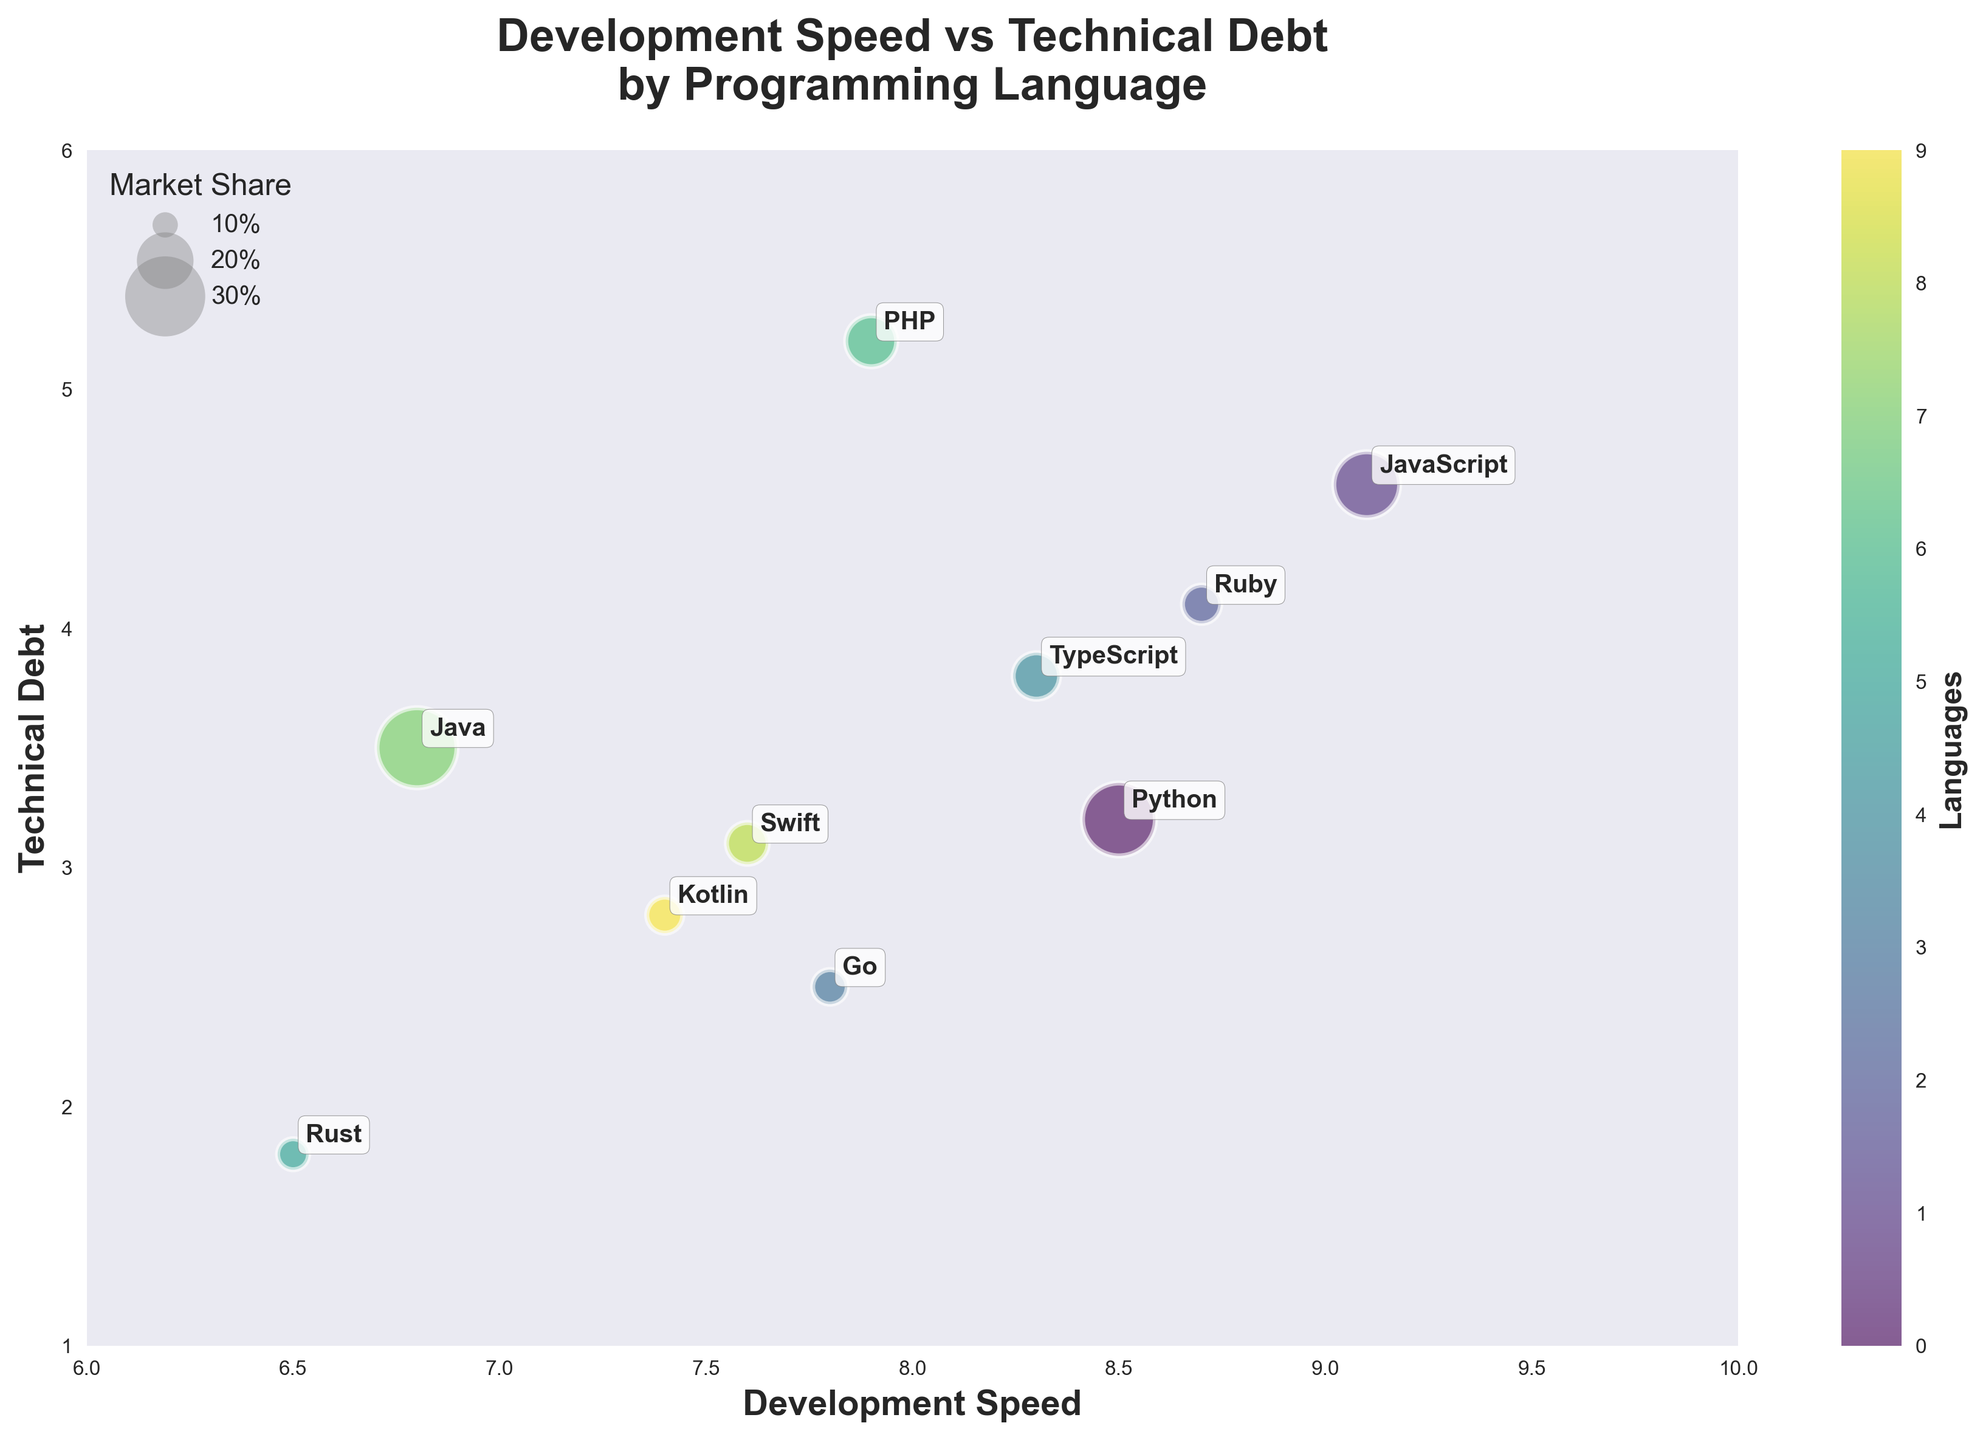Which programming language has the highest development speed? The highest development speed on the x-axis is 9.1, which corresponds to JavaScript.
Answer: JavaScript What is the technical debt level for Rust? Rust’s position on the y-axis shows a technical debt level of 1.8.
Answer: 1.8 What does the size of the bubbles represent? According to the legend and plot specification, the size of the bubbles represents the market share of each programming language.
Answer: Market share Which programming language has the largest market share? Observing the bubble chart, the largest bubble corresponds to Java, indicating it has the largest market share.
Answer: Java Compare the technical debt between Python and Ruby. Python has a technical debt level of 3.2, while Ruby has a technical debt level of 4.1. Therefore, Ruby has higher technical debt.
Answer: Ruby What is the difference in development speed between the fastest and the slowest languages? The fastest language is JavaScript with 9.1, and the slowest is Rust with 6.5. The difference is 9.1 - 6.5 = 2.6.
Answer: 2.6 Which language has the highest technical debt? The highest technical debt level on the y-axis is 5.2, corresponding to PHP.
Answer: PHP Identify a programming language with high development speed but low technical debt. Go has a development speed of 7.8 and a relatively low technical debt of 2.5.
Answer: Go How do TypeScript and Kotlin compare in terms of both development speed and technical debt? TypeScript has a development speed of 8.3 and technical debt of 3.8, while Kotlin has a development speed of 7.4 and technical debt of 2.8. TypeScript is faster but has higher technical debt than Kotlin.
Answer: TypeScript is faster but has higher technical debt What is the average development speed of all shown programming languages? Sum the development speeds: 8.5 + 9.1 + 8.7 + 7.8 + 8.3 + 6.5 + 7.9 + 6.8 + 7.6 + 7.4 = 78.6. Divide by the total number of languages (10), 78.6 / 10 = 7.86.
Answer: 7.86 